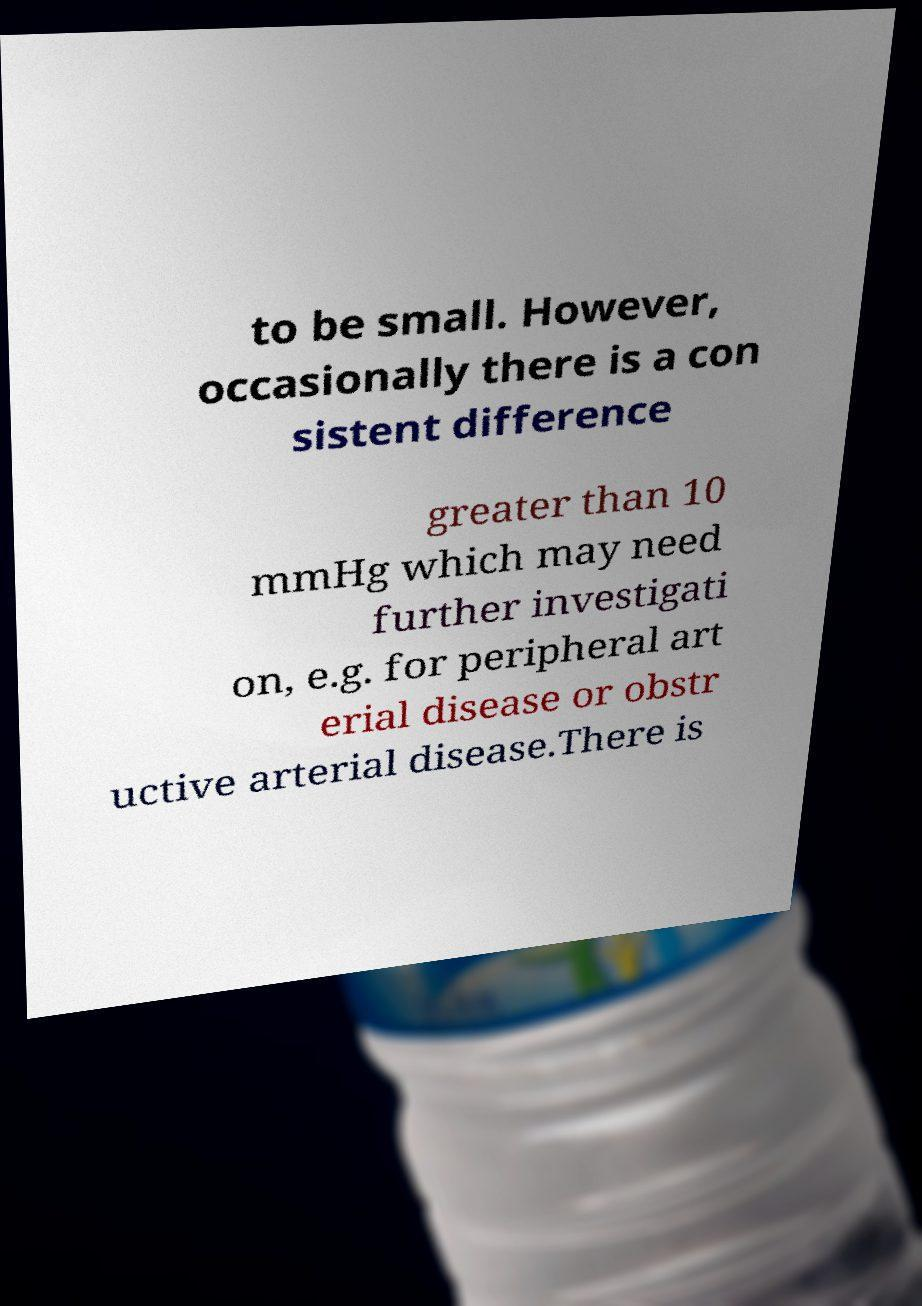Please identify and transcribe the text found in this image. to be small. However, occasionally there is a con sistent difference greater than 10 mmHg which may need further investigati on, e.g. for peripheral art erial disease or obstr uctive arterial disease.There is 